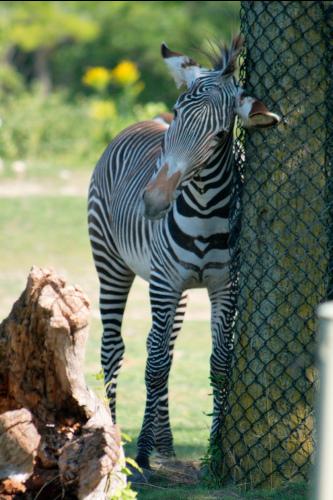Is the animals ears droopy?
Be succinct. No. Is the zebra looking for food?
Write a very short answer. No. Is the zebra in a dry landscape?
Short answer required. Yes. What animal is shown?
Short answer required. Zebra. Is the zebra thirsty?
Short answer required. No. Does the tree trunk have a net around it?
Answer briefly. Yes. Does this zebra live in the wild?
Concise answer only. No. What is the zebra lying on?
Give a very brief answer. Tree. Is the wood petrified?
Be succinct. Yes. What is the fence made out of?
Give a very brief answer. Metal. 